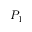Convert formula to latex. <formula><loc_0><loc_0><loc_500><loc_500>P _ { 1 }</formula> 